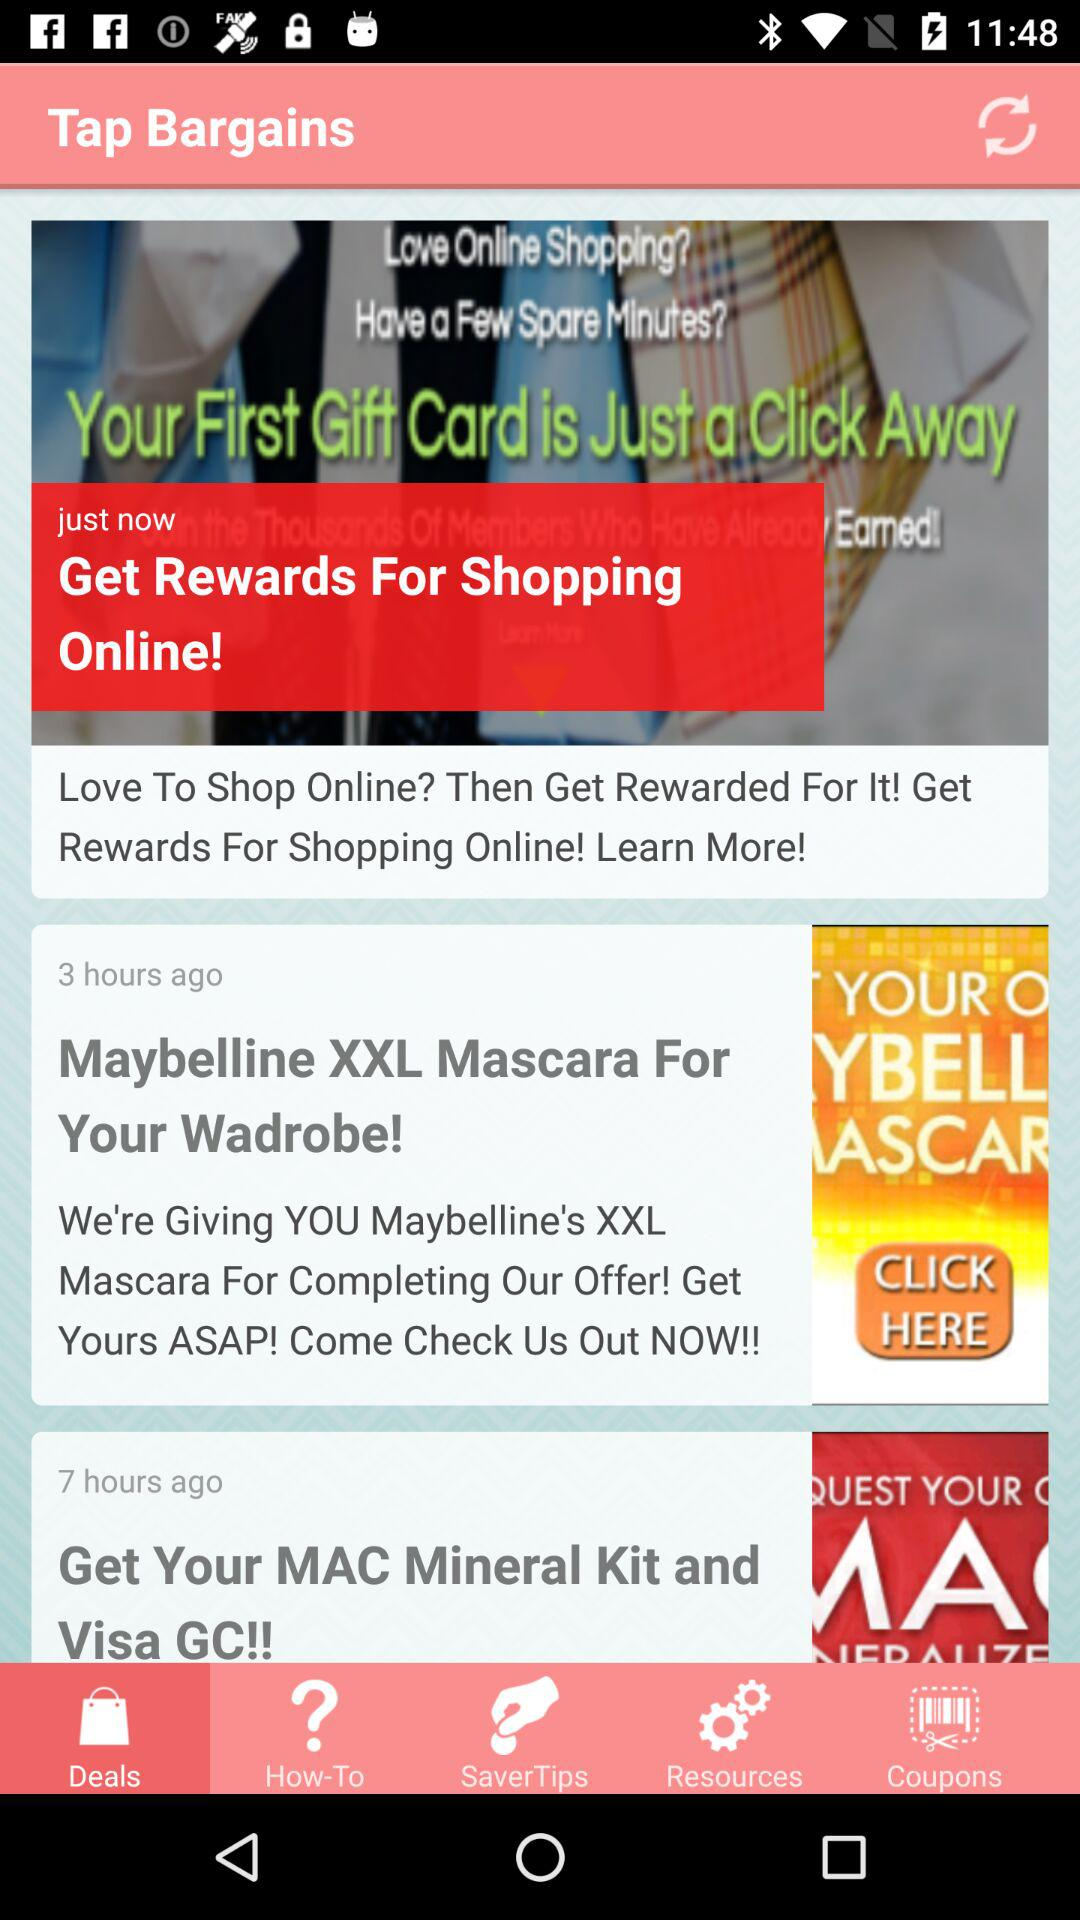Which tab is selected? The selected tab is "Deals". 